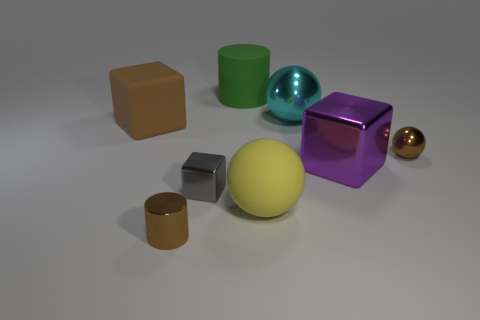Add 2 small brown metallic balls. How many objects exist? 10 Subtract all yellow balls. How many balls are left? 2 Subtract all metallic balls. How many balls are left? 1 Subtract all cylinders. How many objects are left? 6 Subtract 1 cylinders. How many cylinders are left? 1 Add 1 objects. How many objects are left? 9 Add 4 large brown matte objects. How many large brown matte objects exist? 5 Subtract 1 gray blocks. How many objects are left? 7 Subtract all green cubes. Subtract all green cylinders. How many cubes are left? 3 Subtract all green cylinders. How many brown balls are left? 1 